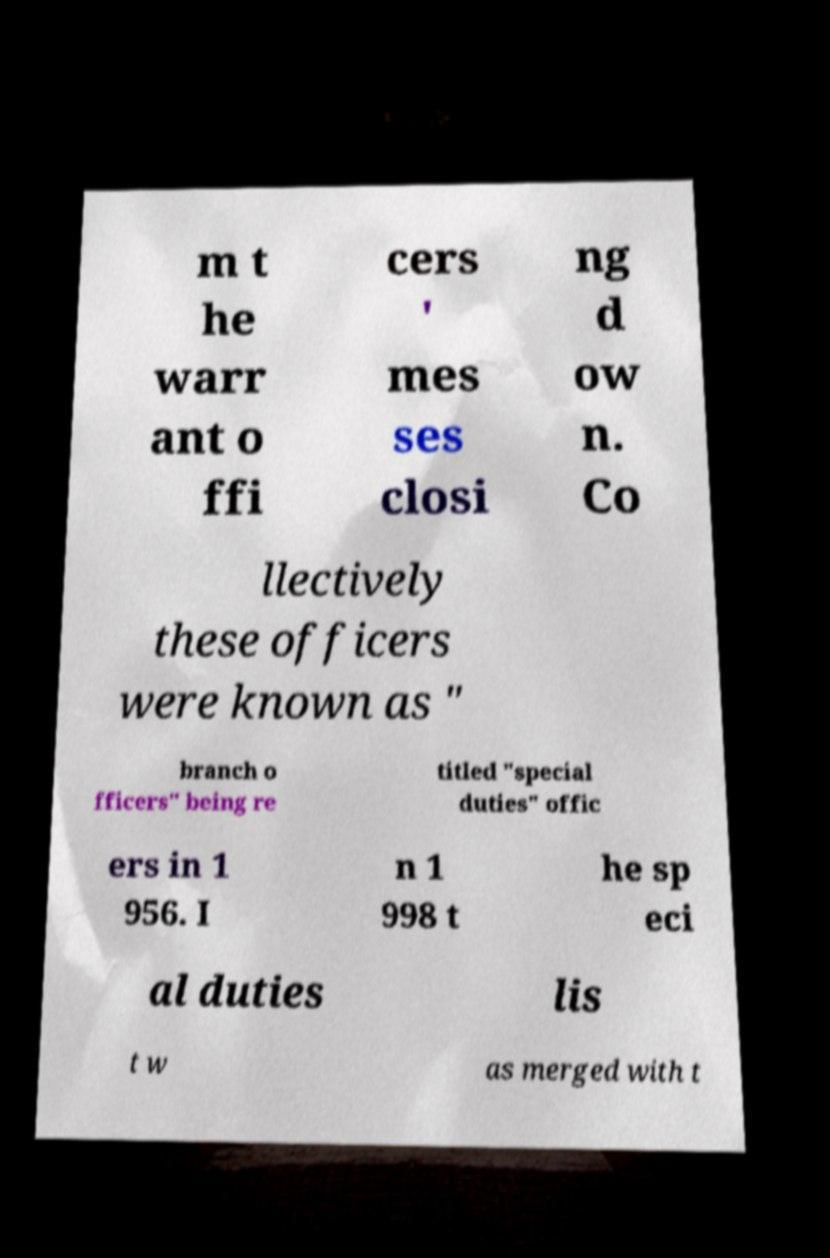Could you extract and type out the text from this image? m t he warr ant o ffi cers ' mes ses closi ng d ow n. Co llectively these officers were known as " branch o fficers" being re titled "special duties" offic ers in 1 956. I n 1 998 t he sp eci al duties lis t w as merged with t 